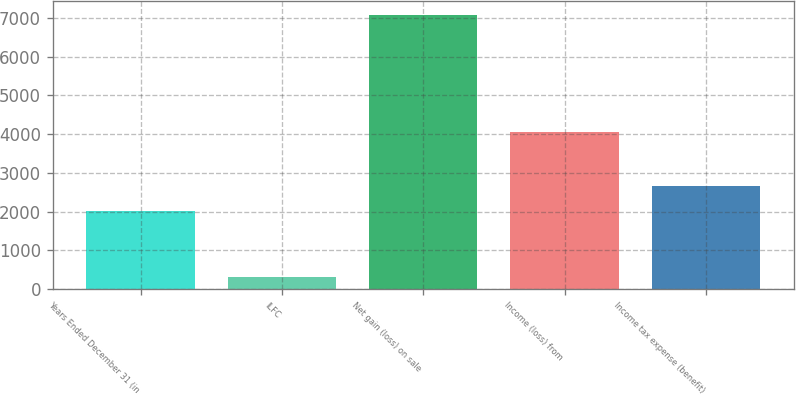Convert chart to OTSL. <chart><loc_0><loc_0><loc_500><loc_500><bar_chart><fcel>Years Ended December 31 (in<fcel>ILFC<fcel>Net gain (loss) on sale<fcel>Income (loss) from<fcel>Income tax expense (benefit)<nl><fcel>2012<fcel>304<fcel>7071.9<fcel>4052<fcel>2654.9<nl></chart> 